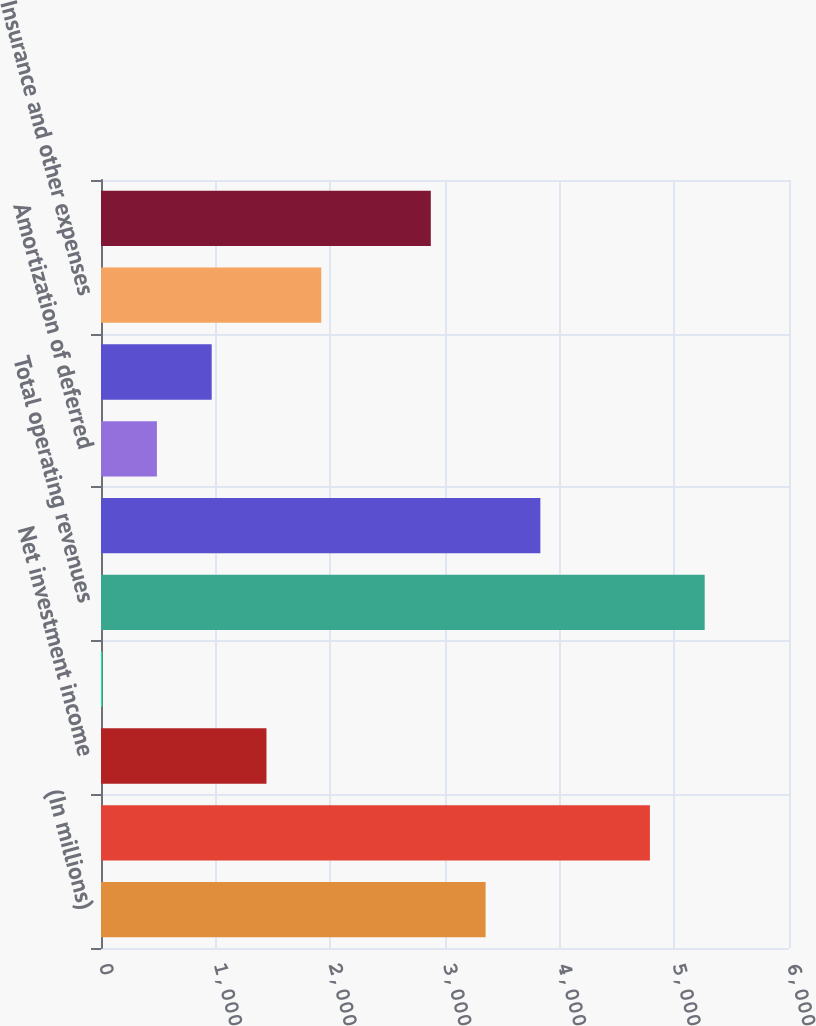Convert chart to OTSL. <chart><loc_0><loc_0><loc_500><loc_500><bar_chart><fcel>(In millions)<fcel>Premium income<fcel>Net investment income<fcel>Other income<fcel>Total operating revenues<fcel>Benefits and claims<fcel>Amortization of deferred<fcel>Insurance commissions<fcel>Insurance and other expenses<fcel>Total operating expenses<nl><fcel>3353.9<fcel>4787<fcel>1443.1<fcel>10<fcel>5264.7<fcel>3831.6<fcel>487.7<fcel>965.4<fcel>1920.8<fcel>2876.2<nl></chart> 